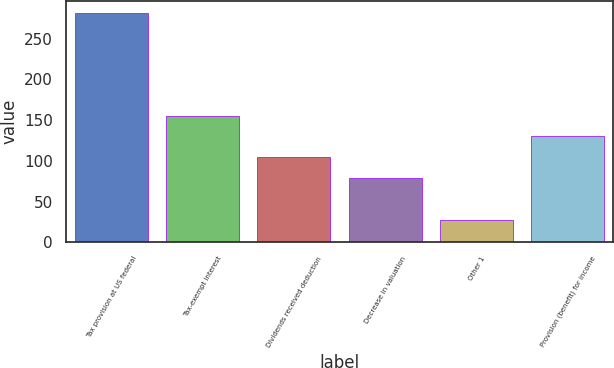<chart> <loc_0><loc_0><loc_500><loc_500><bar_chart><fcel>Tax provision at US federal<fcel>Tax-exempt interest<fcel>Dividends received deduction<fcel>Decrease in valuation<fcel>Other 1<fcel>Provision (benefit) for income<nl><fcel>282<fcel>155.5<fcel>104.5<fcel>79<fcel>27<fcel>130<nl></chart> 